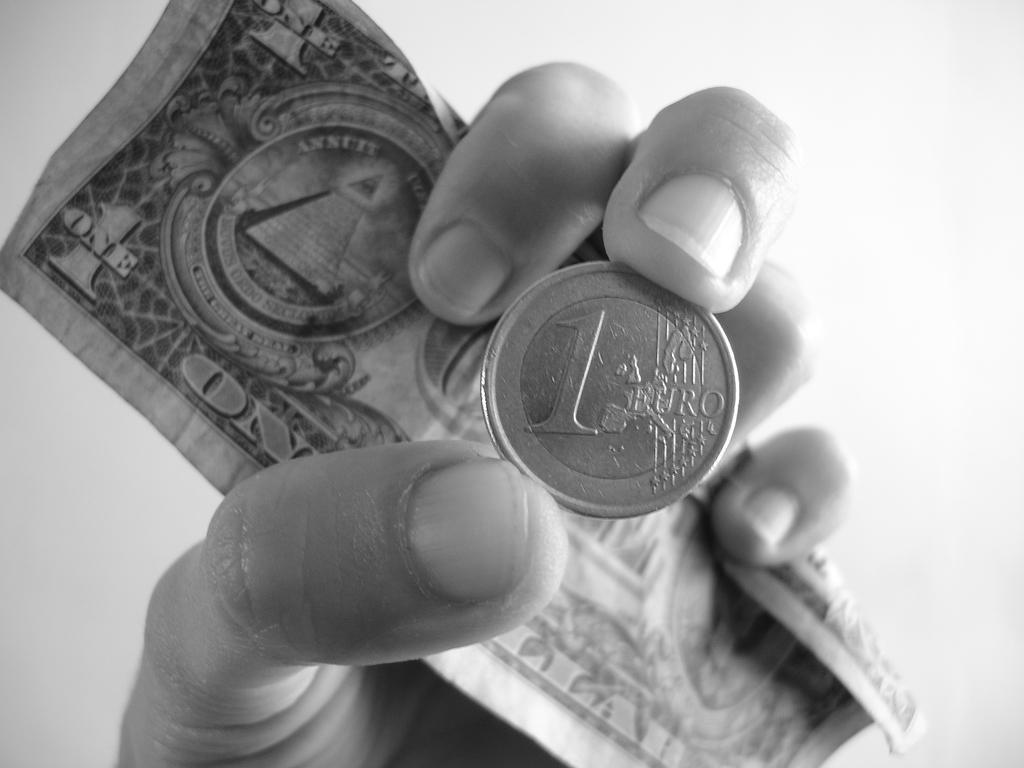What is the main subject of the picture? The main subject of the picture is a human hand. What is the hand holding in the picture? The hand is holding a coin and a dollar note. What can be seen in the background of the picture? There is a plain background in the picture. What type of kite is being flown by the hand in the picture? There is no kite present in the image; the hand is holding a coin and a dollar note. What hobbies does the person holding the coin and dollar note have? The image does not provide information about the person's hobbies. 